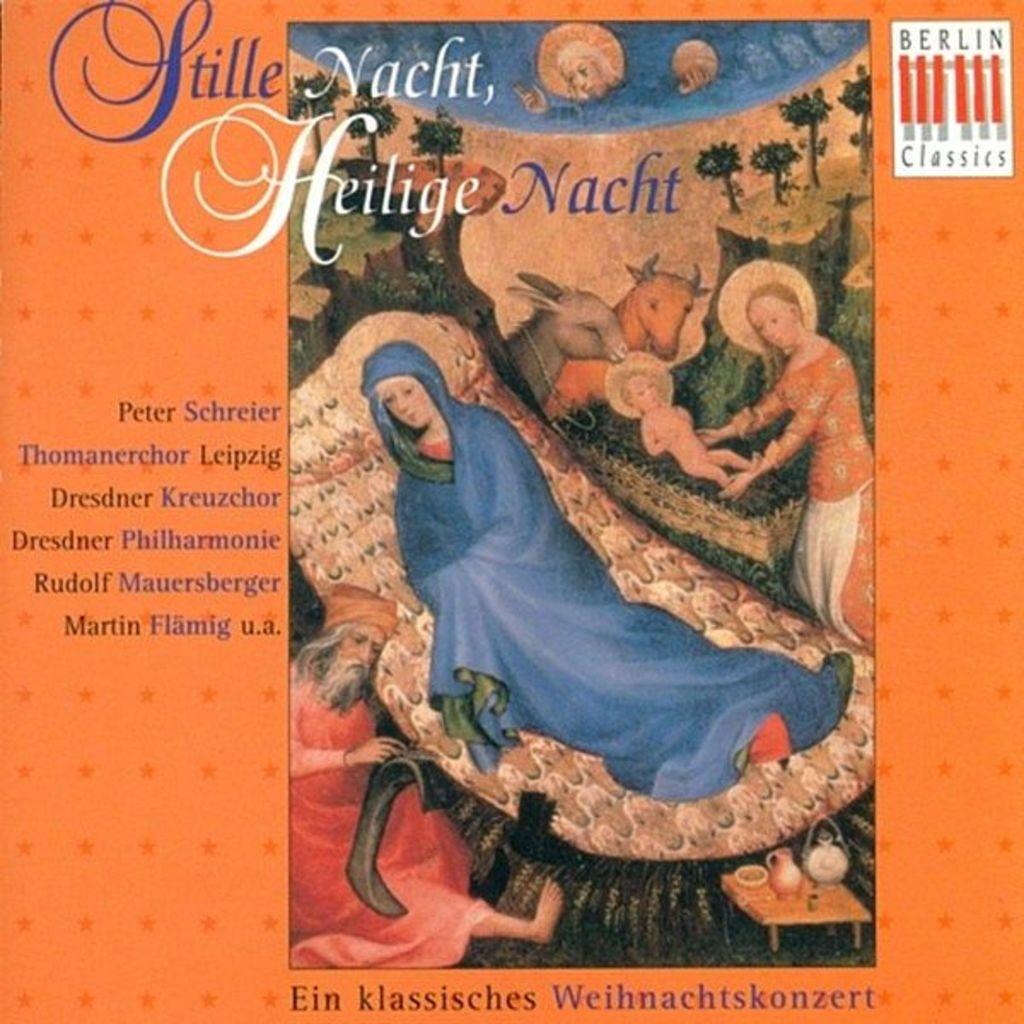Stille nacht, and what?
Provide a succinct answer. Heilige nacht. What logo is on the upper right?
Provide a succinct answer. Berlin classics. 